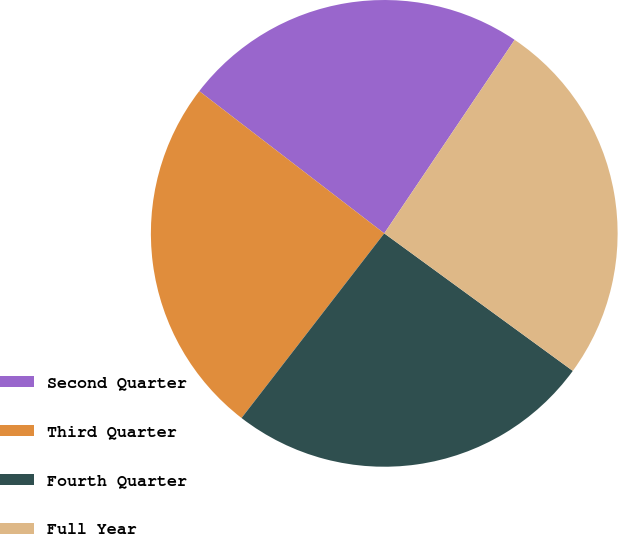Convert chart. <chart><loc_0><loc_0><loc_500><loc_500><pie_chart><fcel>Second Quarter<fcel>Third Quarter<fcel>Fourth Quarter<fcel>Full Year<nl><fcel>24.0%<fcel>24.96%<fcel>25.44%<fcel>25.59%<nl></chart> 